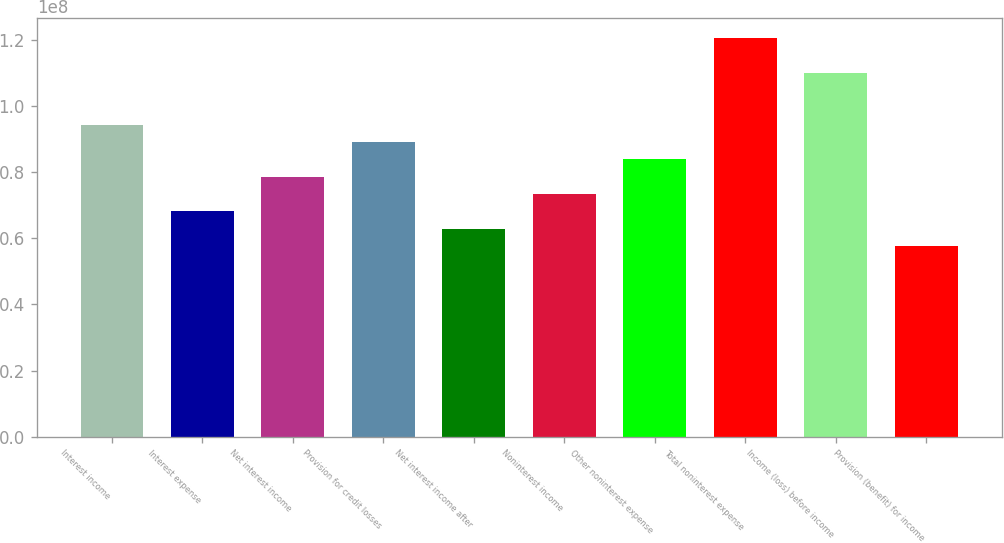<chart> <loc_0><loc_0><loc_500><loc_500><bar_chart><fcel>Interest income<fcel>Interest expense<fcel>Net interest income<fcel>Provision for credit losses<fcel>Net interest income after<fcel>Noninterest income<fcel>Other noninterest expense<fcel>Total noninterest expense<fcel>Income (loss) before income<fcel>Provision (benefit) for income<nl><fcel>9.43925e+07<fcel>6.81723e+07<fcel>7.86604e+07<fcel>8.91485e+07<fcel>6.29283e+07<fcel>7.34164e+07<fcel>8.39044e+07<fcel>1.20613e+08<fcel>1.10125e+08<fcel>5.76843e+07<nl></chart> 